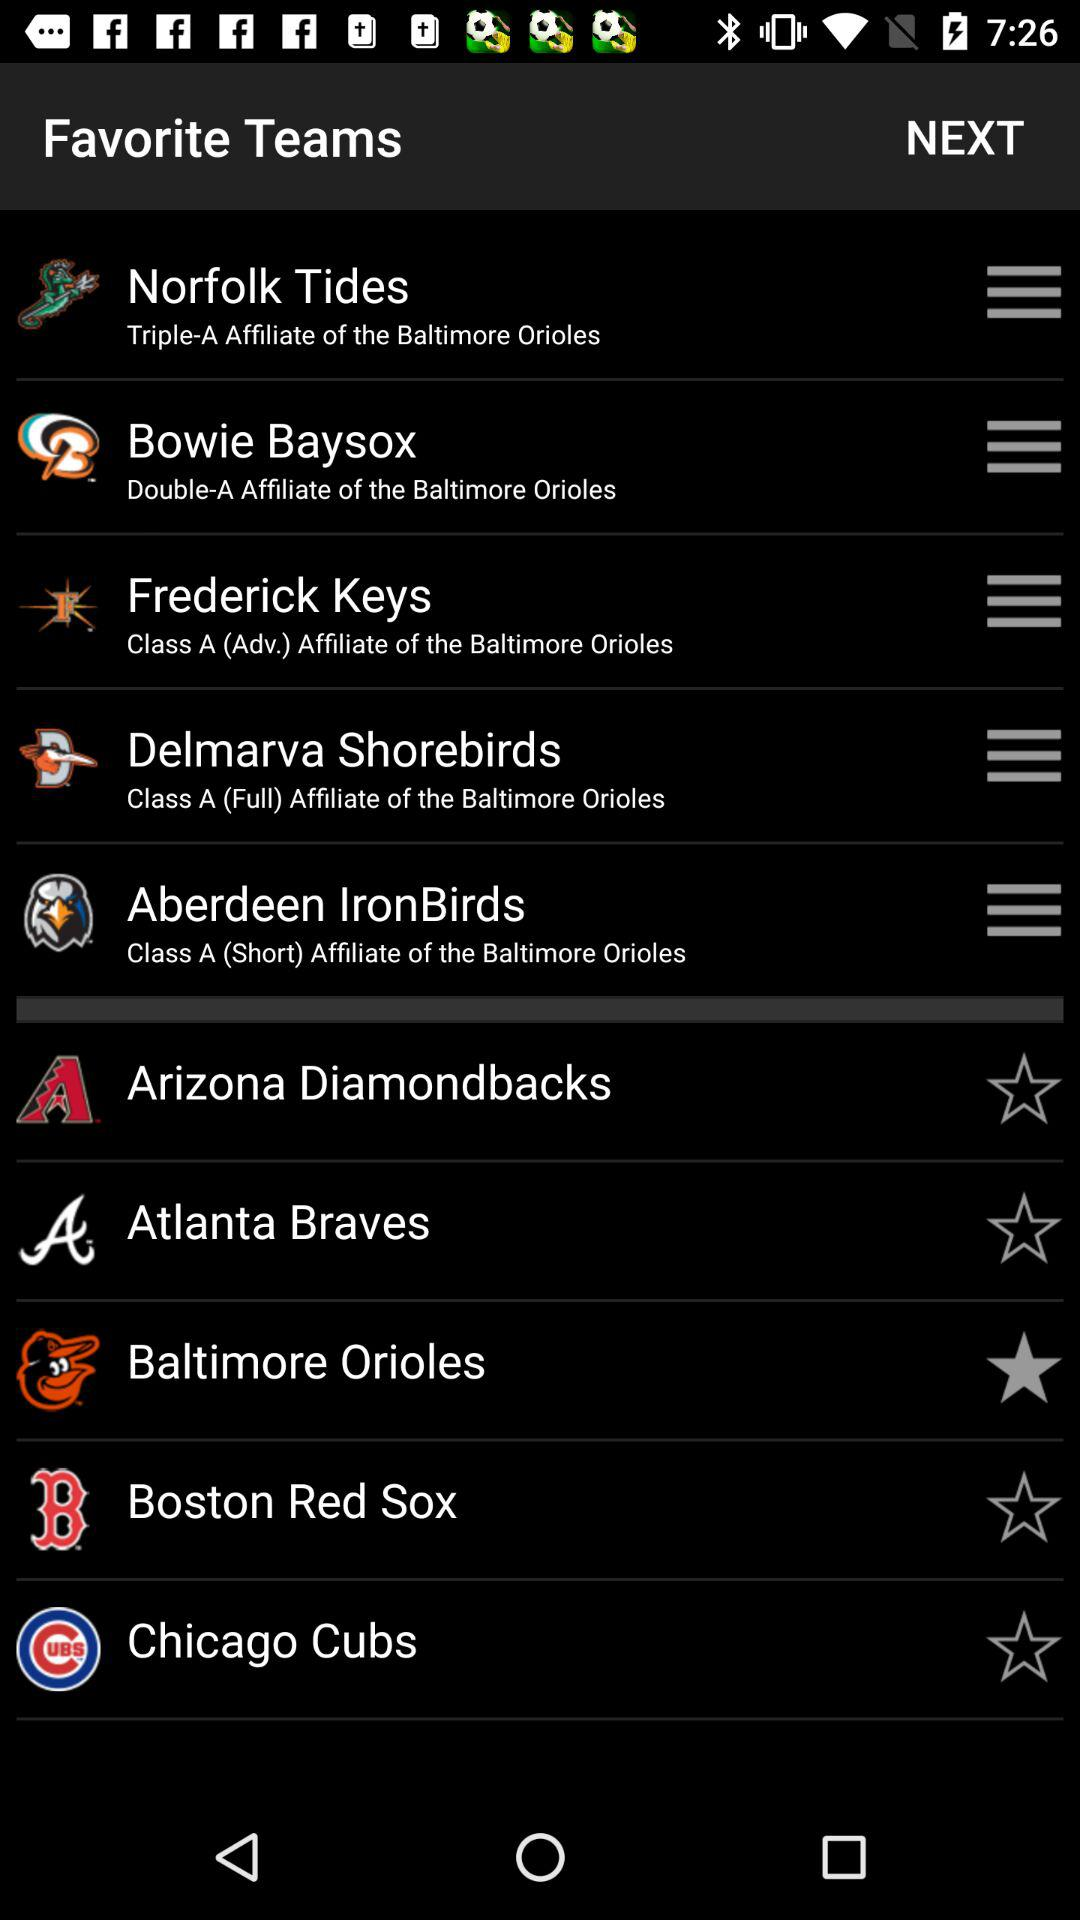How many teams are affiliated with the Baltimore Orioles?
Answer the question using a single word or phrase. 5 